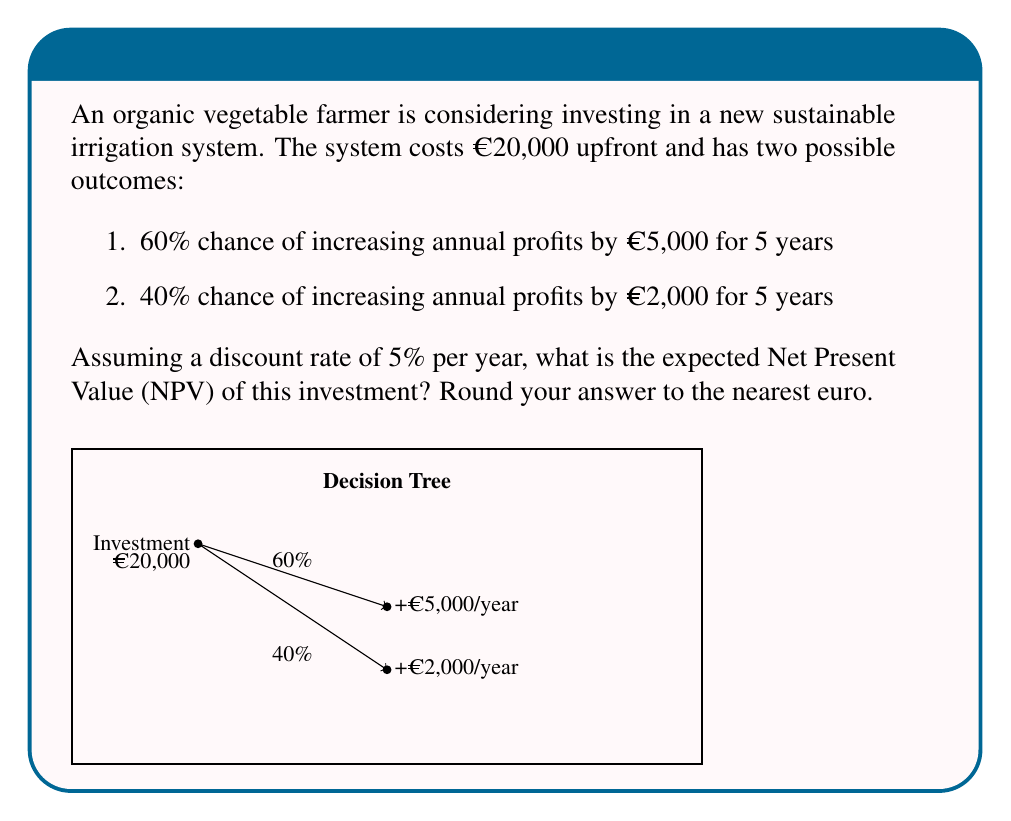Help me with this question. Let's approach this problem step-by-step:

1) First, we need to calculate the Present Value (PV) of each outcome:

   For the 60% chance scenario:
   PV = $\sum_{t=1}^5 \frac{5000}{(1.05)^t}$

   For the 40% chance scenario:
   PV = $\sum_{t=1}^5 \frac{2000}{(1.05)^t}$

2) Let's calculate these sums:

   PV (60% scenario) = 5000 * (1/1.05 + 1/1.05^2 + 1/1.05^3 + 1/1.05^4 + 1/1.05^5)
                     ≈ €21,657.38

   PV (40% scenario) = 2000 * (1/1.05 + 1/1.05^2 + 1/1.05^3 + 1/1.05^4 + 1/1.05^5)
                     ≈ €8,662.95

3) Now, we calculate the Expected Value (EV) of these outcomes:

   EV = 0.60 * €21,657.38 + 0.40 * €8,662.95
      = €12,994.43 + €3,465.18
      = €16,459.61

4) The Net Present Value (NPV) is the difference between this Expected Value and the initial investment:

   NPV = €16,459.61 - €20,000 = -€3,540.39

5) Rounding to the nearest euro:

   NPV ≈ -€3,540
Answer: -€3,540 